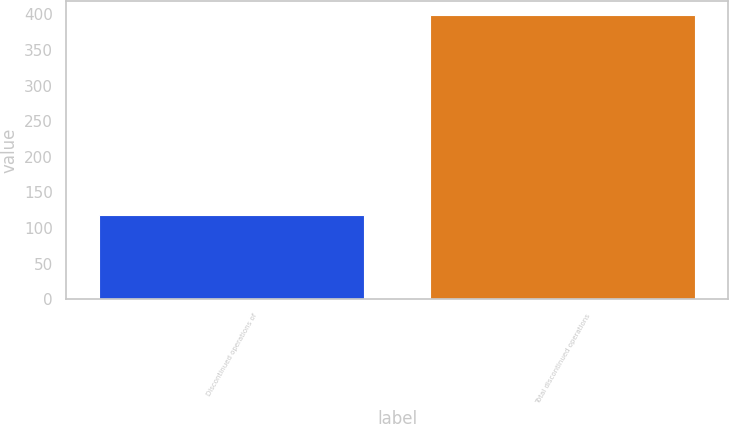Convert chart. <chart><loc_0><loc_0><loc_500><loc_500><bar_chart><fcel>Discontinued operations of<fcel>Total discontinued operations<nl><fcel>118<fcel>399<nl></chart> 